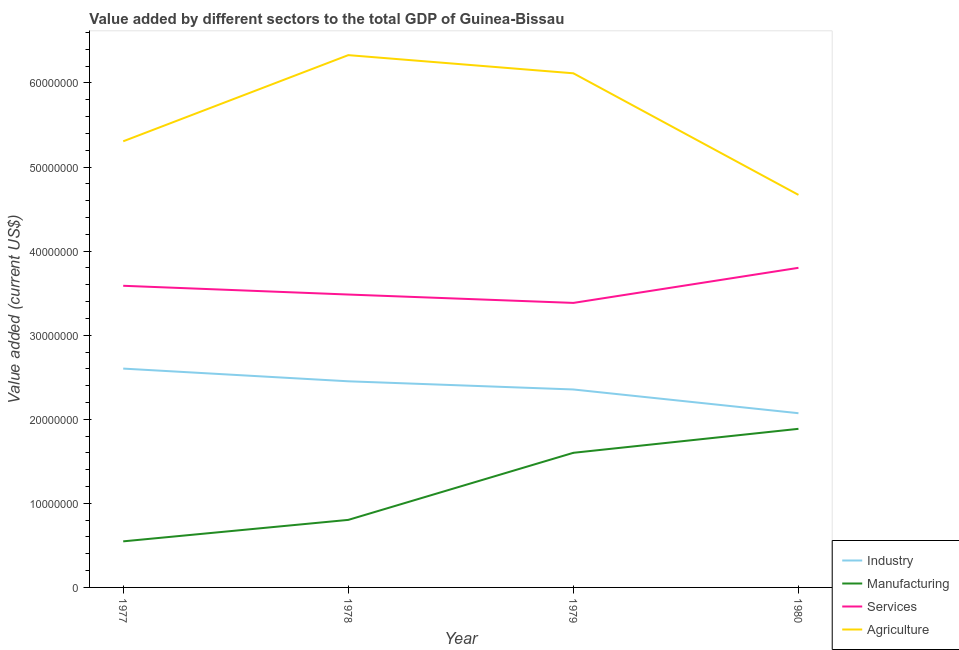Does the line corresponding to value added by agricultural sector intersect with the line corresponding to value added by services sector?
Make the answer very short. No. Is the number of lines equal to the number of legend labels?
Keep it short and to the point. Yes. What is the value added by agricultural sector in 1980?
Ensure brevity in your answer.  4.67e+07. Across all years, what is the maximum value added by services sector?
Give a very brief answer. 3.80e+07. Across all years, what is the minimum value added by industrial sector?
Make the answer very short. 2.07e+07. In which year was the value added by manufacturing sector minimum?
Offer a terse response. 1977. What is the total value added by industrial sector in the graph?
Offer a very short reply. 9.48e+07. What is the difference between the value added by industrial sector in 1978 and that in 1980?
Ensure brevity in your answer.  3.80e+06. What is the difference between the value added by services sector in 1978 and the value added by manufacturing sector in 1977?
Give a very brief answer. 2.94e+07. What is the average value added by manufacturing sector per year?
Offer a very short reply. 1.21e+07. In the year 1978, what is the difference between the value added by agricultural sector and value added by manufacturing sector?
Your response must be concise. 5.53e+07. In how many years, is the value added by industrial sector greater than 56000000 US$?
Make the answer very short. 0. What is the ratio of the value added by agricultural sector in 1977 to that in 1979?
Provide a short and direct response. 0.87. Is the value added by manufacturing sector in 1977 less than that in 1978?
Offer a very short reply. Yes. Is the difference between the value added by industrial sector in 1977 and 1980 greater than the difference between the value added by services sector in 1977 and 1980?
Keep it short and to the point. Yes. What is the difference between the highest and the second highest value added by agricultural sector?
Your answer should be very brief. 2.16e+06. What is the difference between the highest and the lowest value added by manufacturing sector?
Give a very brief answer. 1.34e+07. In how many years, is the value added by manufacturing sector greater than the average value added by manufacturing sector taken over all years?
Provide a succinct answer. 2. Is the sum of the value added by manufacturing sector in 1978 and 1980 greater than the maximum value added by services sector across all years?
Provide a short and direct response. No. Does the value added by manufacturing sector monotonically increase over the years?
Ensure brevity in your answer.  Yes. Is the value added by agricultural sector strictly less than the value added by services sector over the years?
Make the answer very short. No. Are the values on the major ticks of Y-axis written in scientific E-notation?
Your answer should be very brief. No. Does the graph contain grids?
Offer a very short reply. No. Where does the legend appear in the graph?
Offer a very short reply. Bottom right. What is the title of the graph?
Give a very brief answer. Value added by different sectors to the total GDP of Guinea-Bissau. What is the label or title of the X-axis?
Provide a short and direct response. Year. What is the label or title of the Y-axis?
Give a very brief answer. Value added (current US$). What is the Value added (current US$) in Industry in 1977?
Your answer should be compact. 2.60e+07. What is the Value added (current US$) in Manufacturing in 1977?
Provide a succinct answer. 5.48e+06. What is the Value added (current US$) of Services in 1977?
Your answer should be very brief. 3.59e+07. What is the Value added (current US$) of Agriculture in 1977?
Provide a short and direct response. 5.31e+07. What is the Value added (current US$) of Industry in 1978?
Ensure brevity in your answer.  2.45e+07. What is the Value added (current US$) of Manufacturing in 1978?
Ensure brevity in your answer.  8.03e+06. What is the Value added (current US$) of Services in 1978?
Offer a very short reply. 3.48e+07. What is the Value added (current US$) in Agriculture in 1978?
Your response must be concise. 6.33e+07. What is the Value added (current US$) in Industry in 1979?
Keep it short and to the point. 2.35e+07. What is the Value added (current US$) of Manufacturing in 1979?
Your answer should be compact. 1.60e+07. What is the Value added (current US$) of Services in 1979?
Your answer should be compact. 3.38e+07. What is the Value added (current US$) of Agriculture in 1979?
Your response must be concise. 6.12e+07. What is the Value added (current US$) in Industry in 1980?
Your answer should be very brief. 2.07e+07. What is the Value added (current US$) of Manufacturing in 1980?
Give a very brief answer. 1.89e+07. What is the Value added (current US$) in Services in 1980?
Your answer should be compact. 3.80e+07. What is the Value added (current US$) of Agriculture in 1980?
Provide a short and direct response. 4.67e+07. Across all years, what is the maximum Value added (current US$) in Industry?
Provide a succinct answer. 2.60e+07. Across all years, what is the maximum Value added (current US$) of Manufacturing?
Give a very brief answer. 1.89e+07. Across all years, what is the maximum Value added (current US$) of Services?
Offer a terse response. 3.80e+07. Across all years, what is the maximum Value added (current US$) in Agriculture?
Your answer should be very brief. 6.33e+07. Across all years, what is the minimum Value added (current US$) of Industry?
Keep it short and to the point. 2.07e+07. Across all years, what is the minimum Value added (current US$) in Manufacturing?
Your answer should be very brief. 5.48e+06. Across all years, what is the minimum Value added (current US$) in Services?
Your response must be concise. 3.38e+07. Across all years, what is the minimum Value added (current US$) in Agriculture?
Your response must be concise. 4.67e+07. What is the total Value added (current US$) in Industry in the graph?
Ensure brevity in your answer.  9.48e+07. What is the total Value added (current US$) in Manufacturing in the graph?
Your response must be concise. 4.84e+07. What is the total Value added (current US$) of Services in the graph?
Offer a terse response. 1.43e+08. What is the total Value added (current US$) of Agriculture in the graph?
Your response must be concise. 2.24e+08. What is the difference between the Value added (current US$) of Industry in 1977 and that in 1978?
Give a very brief answer. 1.51e+06. What is the difference between the Value added (current US$) of Manufacturing in 1977 and that in 1978?
Your answer should be very brief. -2.55e+06. What is the difference between the Value added (current US$) in Services in 1977 and that in 1978?
Offer a terse response. 1.04e+06. What is the difference between the Value added (current US$) of Agriculture in 1977 and that in 1978?
Ensure brevity in your answer.  -1.02e+07. What is the difference between the Value added (current US$) in Industry in 1977 and that in 1979?
Your answer should be very brief. 2.48e+06. What is the difference between the Value added (current US$) of Manufacturing in 1977 and that in 1979?
Give a very brief answer. -1.05e+07. What is the difference between the Value added (current US$) of Services in 1977 and that in 1979?
Keep it short and to the point. 2.04e+06. What is the difference between the Value added (current US$) in Agriculture in 1977 and that in 1979?
Keep it short and to the point. -8.09e+06. What is the difference between the Value added (current US$) in Industry in 1977 and that in 1980?
Make the answer very short. 5.31e+06. What is the difference between the Value added (current US$) in Manufacturing in 1977 and that in 1980?
Offer a terse response. -1.34e+07. What is the difference between the Value added (current US$) in Services in 1977 and that in 1980?
Keep it short and to the point. -2.14e+06. What is the difference between the Value added (current US$) of Agriculture in 1977 and that in 1980?
Offer a very short reply. 6.37e+06. What is the difference between the Value added (current US$) in Industry in 1978 and that in 1979?
Ensure brevity in your answer.  9.73e+05. What is the difference between the Value added (current US$) in Manufacturing in 1978 and that in 1979?
Provide a succinct answer. -7.98e+06. What is the difference between the Value added (current US$) in Services in 1978 and that in 1979?
Make the answer very short. 9.96e+05. What is the difference between the Value added (current US$) in Agriculture in 1978 and that in 1979?
Your answer should be very brief. 2.16e+06. What is the difference between the Value added (current US$) in Industry in 1978 and that in 1980?
Your response must be concise. 3.80e+06. What is the difference between the Value added (current US$) in Manufacturing in 1978 and that in 1980?
Your answer should be compact. -1.08e+07. What is the difference between the Value added (current US$) in Services in 1978 and that in 1980?
Your response must be concise. -3.18e+06. What is the difference between the Value added (current US$) in Agriculture in 1978 and that in 1980?
Give a very brief answer. 1.66e+07. What is the difference between the Value added (current US$) of Industry in 1979 and that in 1980?
Offer a terse response. 2.82e+06. What is the difference between the Value added (current US$) in Manufacturing in 1979 and that in 1980?
Make the answer very short. -2.85e+06. What is the difference between the Value added (current US$) of Services in 1979 and that in 1980?
Make the answer very short. -4.17e+06. What is the difference between the Value added (current US$) of Agriculture in 1979 and that in 1980?
Keep it short and to the point. 1.45e+07. What is the difference between the Value added (current US$) of Industry in 1977 and the Value added (current US$) of Manufacturing in 1978?
Your answer should be very brief. 1.80e+07. What is the difference between the Value added (current US$) of Industry in 1977 and the Value added (current US$) of Services in 1978?
Your response must be concise. -8.81e+06. What is the difference between the Value added (current US$) in Industry in 1977 and the Value added (current US$) in Agriculture in 1978?
Keep it short and to the point. -3.73e+07. What is the difference between the Value added (current US$) of Manufacturing in 1977 and the Value added (current US$) of Services in 1978?
Provide a short and direct response. -2.94e+07. What is the difference between the Value added (current US$) of Manufacturing in 1977 and the Value added (current US$) of Agriculture in 1978?
Offer a terse response. -5.78e+07. What is the difference between the Value added (current US$) in Services in 1977 and the Value added (current US$) in Agriculture in 1978?
Keep it short and to the point. -2.74e+07. What is the difference between the Value added (current US$) of Industry in 1977 and the Value added (current US$) of Manufacturing in 1979?
Provide a short and direct response. 1.00e+07. What is the difference between the Value added (current US$) in Industry in 1977 and the Value added (current US$) in Services in 1979?
Keep it short and to the point. -7.81e+06. What is the difference between the Value added (current US$) of Industry in 1977 and the Value added (current US$) of Agriculture in 1979?
Provide a short and direct response. -3.51e+07. What is the difference between the Value added (current US$) in Manufacturing in 1977 and the Value added (current US$) in Services in 1979?
Your answer should be very brief. -2.84e+07. What is the difference between the Value added (current US$) in Manufacturing in 1977 and the Value added (current US$) in Agriculture in 1979?
Make the answer very short. -5.57e+07. What is the difference between the Value added (current US$) in Services in 1977 and the Value added (current US$) in Agriculture in 1979?
Offer a very short reply. -2.53e+07. What is the difference between the Value added (current US$) of Industry in 1977 and the Value added (current US$) of Manufacturing in 1980?
Provide a short and direct response. 7.16e+06. What is the difference between the Value added (current US$) of Industry in 1977 and the Value added (current US$) of Services in 1980?
Provide a short and direct response. -1.20e+07. What is the difference between the Value added (current US$) in Industry in 1977 and the Value added (current US$) in Agriculture in 1980?
Provide a succinct answer. -2.07e+07. What is the difference between the Value added (current US$) of Manufacturing in 1977 and the Value added (current US$) of Services in 1980?
Keep it short and to the point. -3.25e+07. What is the difference between the Value added (current US$) of Manufacturing in 1977 and the Value added (current US$) of Agriculture in 1980?
Provide a short and direct response. -4.12e+07. What is the difference between the Value added (current US$) of Services in 1977 and the Value added (current US$) of Agriculture in 1980?
Provide a short and direct response. -1.08e+07. What is the difference between the Value added (current US$) in Industry in 1978 and the Value added (current US$) in Manufacturing in 1979?
Give a very brief answer. 8.51e+06. What is the difference between the Value added (current US$) of Industry in 1978 and the Value added (current US$) of Services in 1979?
Offer a very short reply. -9.32e+06. What is the difference between the Value added (current US$) of Industry in 1978 and the Value added (current US$) of Agriculture in 1979?
Provide a short and direct response. -3.66e+07. What is the difference between the Value added (current US$) of Manufacturing in 1978 and the Value added (current US$) of Services in 1979?
Keep it short and to the point. -2.58e+07. What is the difference between the Value added (current US$) in Manufacturing in 1978 and the Value added (current US$) in Agriculture in 1979?
Your response must be concise. -5.31e+07. What is the difference between the Value added (current US$) in Services in 1978 and the Value added (current US$) in Agriculture in 1979?
Provide a succinct answer. -2.63e+07. What is the difference between the Value added (current US$) in Industry in 1978 and the Value added (current US$) in Manufacturing in 1980?
Provide a succinct answer. 5.65e+06. What is the difference between the Value added (current US$) of Industry in 1978 and the Value added (current US$) of Services in 1980?
Keep it short and to the point. -1.35e+07. What is the difference between the Value added (current US$) of Industry in 1978 and the Value added (current US$) of Agriculture in 1980?
Provide a succinct answer. -2.22e+07. What is the difference between the Value added (current US$) in Manufacturing in 1978 and the Value added (current US$) in Services in 1980?
Your answer should be compact. -3.00e+07. What is the difference between the Value added (current US$) of Manufacturing in 1978 and the Value added (current US$) of Agriculture in 1980?
Your answer should be compact. -3.87e+07. What is the difference between the Value added (current US$) in Services in 1978 and the Value added (current US$) in Agriculture in 1980?
Keep it short and to the point. -1.19e+07. What is the difference between the Value added (current US$) in Industry in 1979 and the Value added (current US$) in Manufacturing in 1980?
Provide a succinct answer. 4.68e+06. What is the difference between the Value added (current US$) in Industry in 1979 and the Value added (current US$) in Services in 1980?
Offer a terse response. -1.45e+07. What is the difference between the Value added (current US$) in Industry in 1979 and the Value added (current US$) in Agriculture in 1980?
Give a very brief answer. -2.31e+07. What is the difference between the Value added (current US$) of Manufacturing in 1979 and the Value added (current US$) of Services in 1980?
Keep it short and to the point. -2.20e+07. What is the difference between the Value added (current US$) in Manufacturing in 1979 and the Value added (current US$) in Agriculture in 1980?
Keep it short and to the point. -3.07e+07. What is the difference between the Value added (current US$) in Services in 1979 and the Value added (current US$) in Agriculture in 1980?
Your response must be concise. -1.28e+07. What is the average Value added (current US$) in Industry per year?
Keep it short and to the point. 2.37e+07. What is the average Value added (current US$) in Manufacturing per year?
Your answer should be compact. 1.21e+07. What is the average Value added (current US$) in Services per year?
Provide a succinct answer. 3.56e+07. What is the average Value added (current US$) in Agriculture per year?
Keep it short and to the point. 5.61e+07. In the year 1977, what is the difference between the Value added (current US$) of Industry and Value added (current US$) of Manufacturing?
Your answer should be very brief. 2.05e+07. In the year 1977, what is the difference between the Value added (current US$) of Industry and Value added (current US$) of Services?
Make the answer very short. -9.85e+06. In the year 1977, what is the difference between the Value added (current US$) in Industry and Value added (current US$) in Agriculture?
Your answer should be very brief. -2.70e+07. In the year 1977, what is the difference between the Value added (current US$) of Manufacturing and Value added (current US$) of Services?
Ensure brevity in your answer.  -3.04e+07. In the year 1977, what is the difference between the Value added (current US$) of Manufacturing and Value added (current US$) of Agriculture?
Your response must be concise. -4.76e+07. In the year 1977, what is the difference between the Value added (current US$) in Services and Value added (current US$) in Agriculture?
Keep it short and to the point. -1.72e+07. In the year 1978, what is the difference between the Value added (current US$) in Industry and Value added (current US$) in Manufacturing?
Make the answer very short. 1.65e+07. In the year 1978, what is the difference between the Value added (current US$) in Industry and Value added (current US$) in Services?
Provide a short and direct response. -1.03e+07. In the year 1978, what is the difference between the Value added (current US$) of Industry and Value added (current US$) of Agriculture?
Keep it short and to the point. -3.88e+07. In the year 1978, what is the difference between the Value added (current US$) in Manufacturing and Value added (current US$) in Services?
Ensure brevity in your answer.  -2.68e+07. In the year 1978, what is the difference between the Value added (current US$) in Manufacturing and Value added (current US$) in Agriculture?
Make the answer very short. -5.53e+07. In the year 1978, what is the difference between the Value added (current US$) in Services and Value added (current US$) in Agriculture?
Your answer should be very brief. -2.85e+07. In the year 1979, what is the difference between the Value added (current US$) in Industry and Value added (current US$) in Manufacturing?
Keep it short and to the point. 7.53e+06. In the year 1979, what is the difference between the Value added (current US$) in Industry and Value added (current US$) in Services?
Your answer should be very brief. -1.03e+07. In the year 1979, what is the difference between the Value added (current US$) in Industry and Value added (current US$) in Agriculture?
Offer a very short reply. -3.76e+07. In the year 1979, what is the difference between the Value added (current US$) in Manufacturing and Value added (current US$) in Services?
Offer a very short reply. -1.78e+07. In the year 1979, what is the difference between the Value added (current US$) in Manufacturing and Value added (current US$) in Agriculture?
Make the answer very short. -4.51e+07. In the year 1979, what is the difference between the Value added (current US$) of Services and Value added (current US$) of Agriculture?
Ensure brevity in your answer.  -2.73e+07. In the year 1980, what is the difference between the Value added (current US$) of Industry and Value added (current US$) of Manufacturing?
Your answer should be compact. 1.86e+06. In the year 1980, what is the difference between the Value added (current US$) in Industry and Value added (current US$) in Services?
Offer a very short reply. -1.73e+07. In the year 1980, what is the difference between the Value added (current US$) of Industry and Value added (current US$) of Agriculture?
Your response must be concise. -2.60e+07. In the year 1980, what is the difference between the Value added (current US$) of Manufacturing and Value added (current US$) of Services?
Keep it short and to the point. -1.92e+07. In the year 1980, what is the difference between the Value added (current US$) in Manufacturing and Value added (current US$) in Agriculture?
Your answer should be very brief. -2.78e+07. In the year 1980, what is the difference between the Value added (current US$) in Services and Value added (current US$) in Agriculture?
Your response must be concise. -8.68e+06. What is the ratio of the Value added (current US$) of Industry in 1977 to that in 1978?
Make the answer very short. 1.06. What is the ratio of the Value added (current US$) in Manufacturing in 1977 to that in 1978?
Give a very brief answer. 0.68. What is the ratio of the Value added (current US$) of Services in 1977 to that in 1978?
Make the answer very short. 1.03. What is the ratio of the Value added (current US$) in Agriculture in 1977 to that in 1978?
Offer a very short reply. 0.84. What is the ratio of the Value added (current US$) of Industry in 1977 to that in 1979?
Your response must be concise. 1.11. What is the ratio of the Value added (current US$) in Manufacturing in 1977 to that in 1979?
Your answer should be very brief. 0.34. What is the ratio of the Value added (current US$) of Services in 1977 to that in 1979?
Your response must be concise. 1.06. What is the ratio of the Value added (current US$) in Agriculture in 1977 to that in 1979?
Provide a short and direct response. 0.87. What is the ratio of the Value added (current US$) in Industry in 1977 to that in 1980?
Offer a very short reply. 1.26. What is the ratio of the Value added (current US$) of Manufacturing in 1977 to that in 1980?
Keep it short and to the point. 0.29. What is the ratio of the Value added (current US$) of Services in 1977 to that in 1980?
Make the answer very short. 0.94. What is the ratio of the Value added (current US$) of Agriculture in 1977 to that in 1980?
Your answer should be very brief. 1.14. What is the ratio of the Value added (current US$) of Industry in 1978 to that in 1979?
Your response must be concise. 1.04. What is the ratio of the Value added (current US$) of Manufacturing in 1978 to that in 1979?
Your answer should be very brief. 0.5. What is the ratio of the Value added (current US$) in Services in 1978 to that in 1979?
Ensure brevity in your answer.  1.03. What is the ratio of the Value added (current US$) of Agriculture in 1978 to that in 1979?
Keep it short and to the point. 1.04. What is the ratio of the Value added (current US$) in Industry in 1978 to that in 1980?
Make the answer very short. 1.18. What is the ratio of the Value added (current US$) of Manufacturing in 1978 to that in 1980?
Provide a succinct answer. 0.43. What is the ratio of the Value added (current US$) of Services in 1978 to that in 1980?
Offer a very short reply. 0.92. What is the ratio of the Value added (current US$) of Agriculture in 1978 to that in 1980?
Make the answer very short. 1.36. What is the ratio of the Value added (current US$) in Industry in 1979 to that in 1980?
Ensure brevity in your answer.  1.14. What is the ratio of the Value added (current US$) of Manufacturing in 1979 to that in 1980?
Provide a short and direct response. 0.85. What is the ratio of the Value added (current US$) in Services in 1979 to that in 1980?
Your answer should be compact. 0.89. What is the ratio of the Value added (current US$) of Agriculture in 1979 to that in 1980?
Ensure brevity in your answer.  1.31. What is the difference between the highest and the second highest Value added (current US$) of Industry?
Make the answer very short. 1.51e+06. What is the difference between the highest and the second highest Value added (current US$) in Manufacturing?
Your answer should be very brief. 2.85e+06. What is the difference between the highest and the second highest Value added (current US$) of Services?
Keep it short and to the point. 2.14e+06. What is the difference between the highest and the second highest Value added (current US$) of Agriculture?
Provide a succinct answer. 2.16e+06. What is the difference between the highest and the lowest Value added (current US$) in Industry?
Your response must be concise. 5.31e+06. What is the difference between the highest and the lowest Value added (current US$) of Manufacturing?
Keep it short and to the point. 1.34e+07. What is the difference between the highest and the lowest Value added (current US$) in Services?
Offer a very short reply. 4.17e+06. What is the difference between the highest and the lowest Value added (current US$) in Agriculture?
Your answer should be very brief. 1.66e+07. 